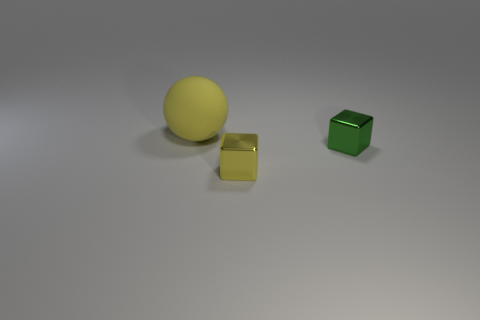What number of other things are there of the same size as the yellow ball?
Offer a terse response. 0. What color is the matte sphere?
Provide a succinct answer. Yellow. What number of metal things are either big spheres or tiny red cylinders?
Your response must be concise. 0. Is there anything else that is the same material as the tiny green block?
Your answer should be compact. Yes. How big is the yellow thing behind the tiny metallic block right of the yellow thing that is in front of the yellow rubber object?
Keep it short and to the point. Large. There is a object that is behind the small yellow thing and on the left side of the tiny green shiny thing; what size is it?
Your answer should be very brief. Large. Is the color of the thing on the left side of the small yellow cube the same as the metallic block that is in front of the tiny green metallic block?
Offer a very short reply. Yes. There is a yellow ball; what number of green things are in front of it?
Your answer should be very brief. 1. Are there any yellow spheres behind the small shiny block that is on the left side of the small thing that is to the right of the tiny yellow block?
Provide a succinct answer. Yes. What number of other metal blocks are the same size as the green block?
Ensure brevity in your answer.  1. 